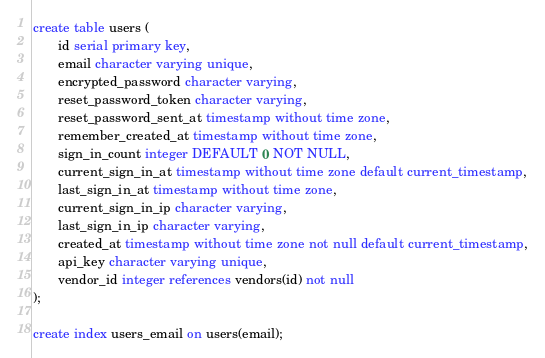Convert code to text. <code><loc_0><loc_0><loc_500><loc_500><_SQL_>create table users (
       id serial primary key,
       email character varying unique,
       encrypted_password character varying,
       reset_password_token character varying,
       reset_password_sent_at timestamp without time zone,
       remember_created_at timestamp without time zone,
       sign_in_count integer DEFAULT 0 NOT NULL,
       current_sign_in_at timestamp without time zone default current_timestamp,
       last_sign_in_at timestamp without time zone,
       current_sign_in_ip character varying,
       last_sign_in_ip character varying,
       created_at timestamp without time zone not null default current_timestamp,
       api_key character varying unique,
       vendor_id integer references vendors(id) not null
);

create index users_email on users(email);
</code> 